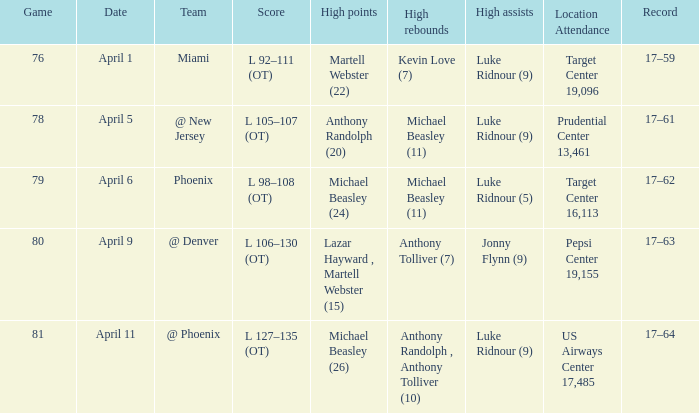In how many distinct games did luke ridnour (5) achieve the highest assists? 1.0. 